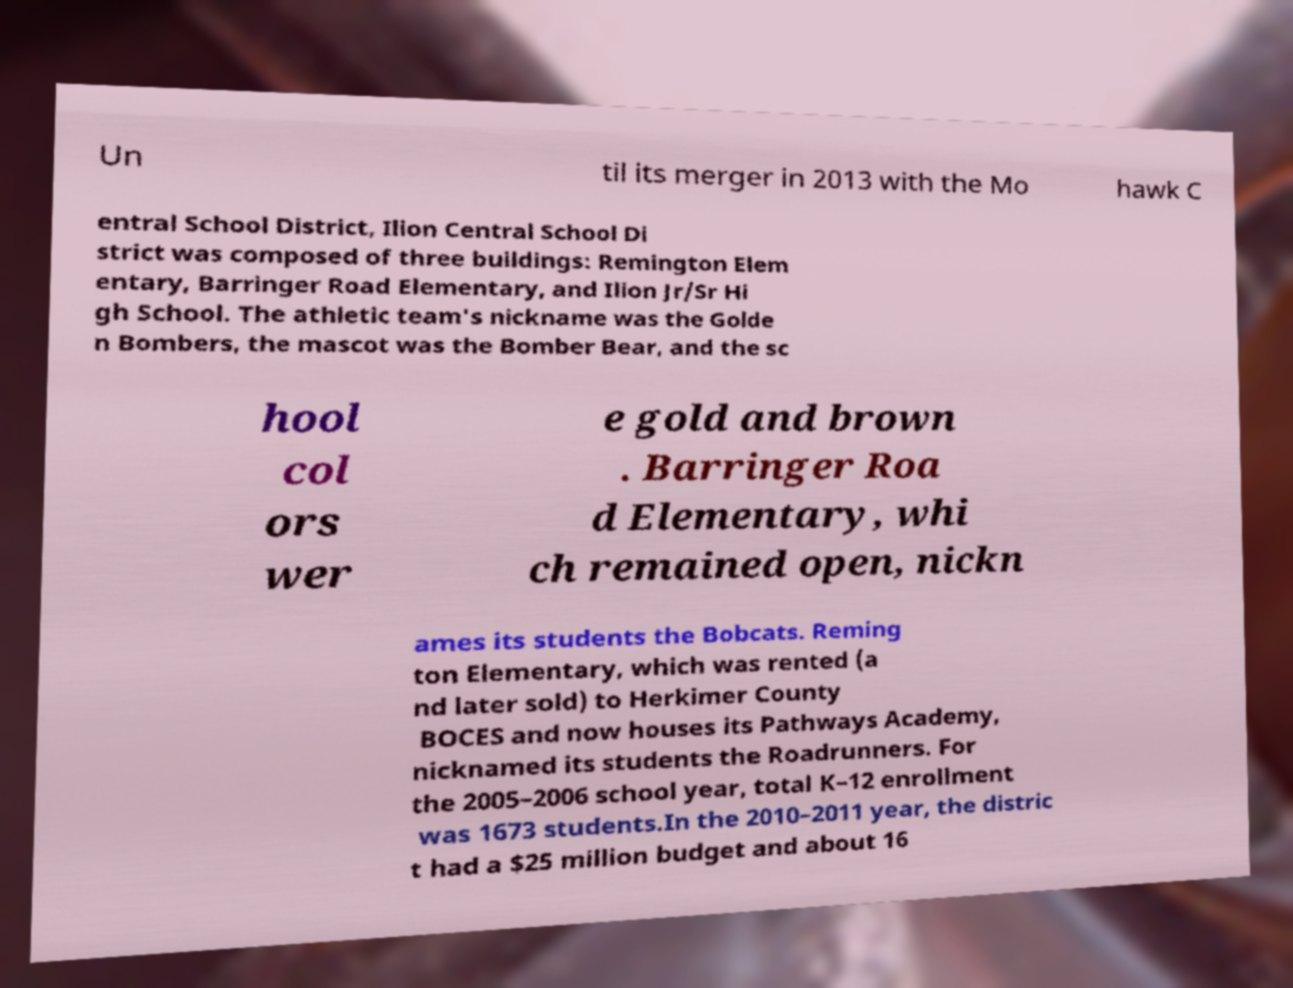I need the written content from this picture converted into text. Can you do that? Un til its merger in 2013 with the Mo hawk C entral School District, Ilion Central School Di strict was composed of three buildings: Remington Elem entary, Barringer Road Elementary, and Ilion Jr/Sr Hi gh School. The athletic team's nickname was the Golde n Bombers, the mascot was the Bomber Bear, and the sc hool col ors wer e gold and brown . Barringer Roa d Elementary, whi ch remained open, nickn ames its students the Bobcats. Reming ton Elementary, which was rented (a nd later sold) to Herkimer County BOCES and now houses its Pathways Academy, nicknamed its students the Roadrunners. For the 2005–2006 school year, total K–12 enrollment was 1673 students.In the 2010–2011 year, the distric t had a $25 million budget and about 16 